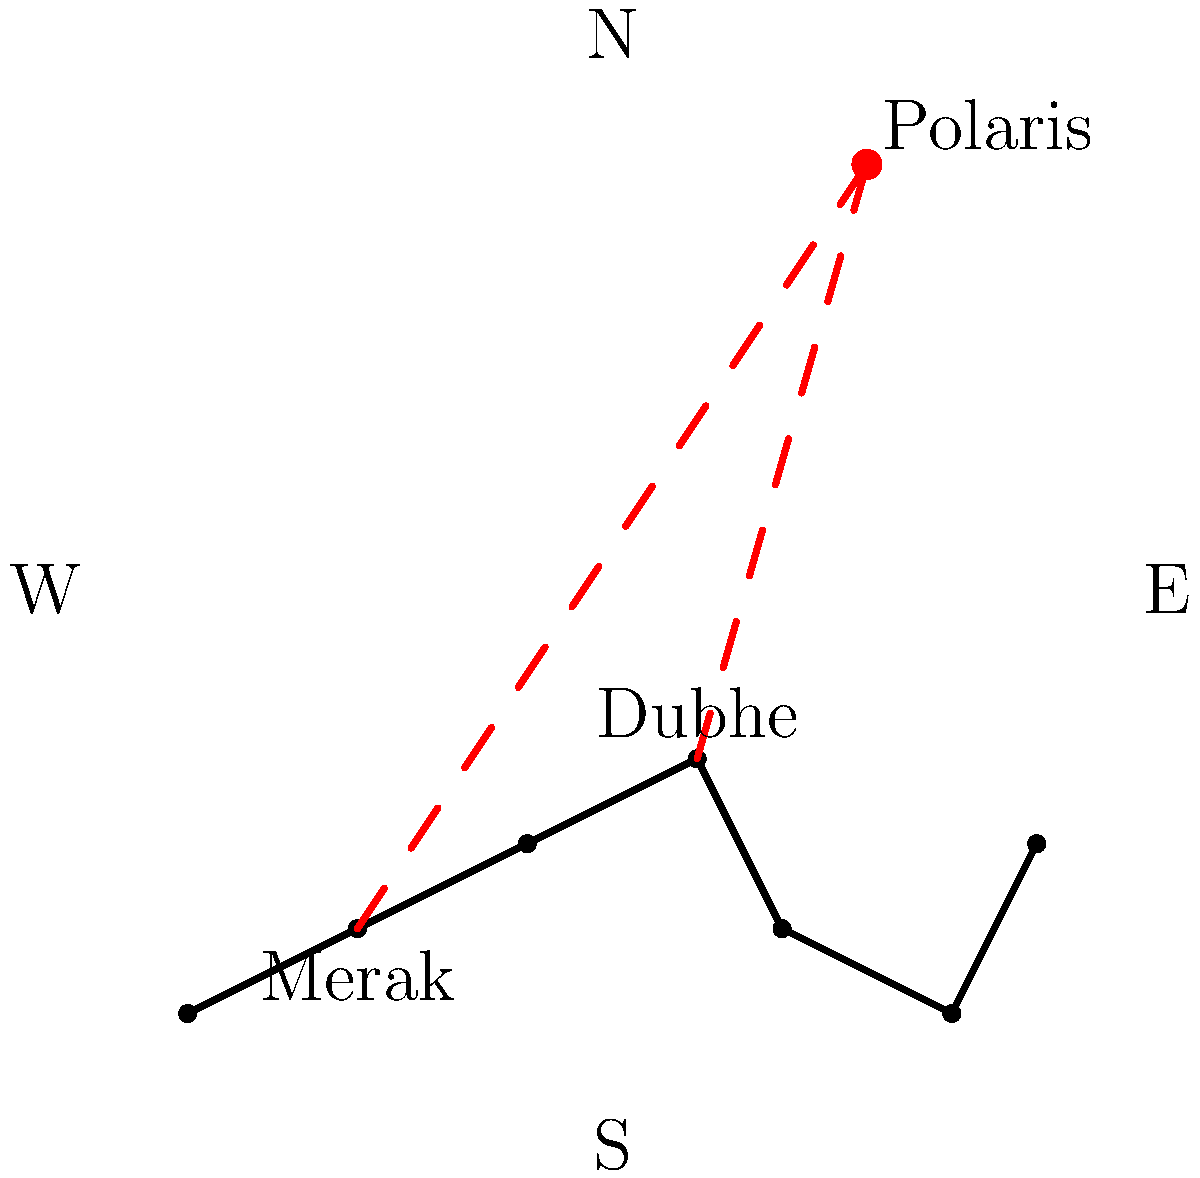As a seasoned lobbyist often navigating Washington D.C. at night, you've become familiar with the night sky. Looking at the Big Dipper constellation, which two stars are used to locate Polaris, the North Star, and how does this relate to finding true north? 1. The Big Dipper is one of the most recognizable constellations in the Northern Hemisphere, often used for navigation.

2. Two stars in the Big Dipper, Dubhe and Merak, are known as the "pointer stars."

3. Dubhe is the star at the front edge of the Big Dipper's "bowl," while Merak is the star at the bottom of the bowl's front edge.

4. To find Polaris:
   a. Locate Dubhe and Merak in the Big Dipper.
   b. Draw an imaginary line from Merak through Dubhe.
   c. Extend this line about 5 times the distance between Merak and Dubhe.
   d. The bright star at the end of this line is Polaris, the North Star.

5. Polaris is significant because:
   a. It remains nearly stationary in the night sky as the Earth rotates.
   b. It's always located within 1° of true celestial north.

6. Finding Polaris allows you to determine true north:
   a. Face Polaris.
   b. The direction you're facing is true north.
   c. This is more accurate than using a magnetic compass, which points to magnetic north.

7. In Washington D.C., as in other locations, this celestial navigation technique remains constant and reliable, unlike potentially shifting political alliances.
Answer: Dubhe and Merak point to Polaris, indicating true north. 